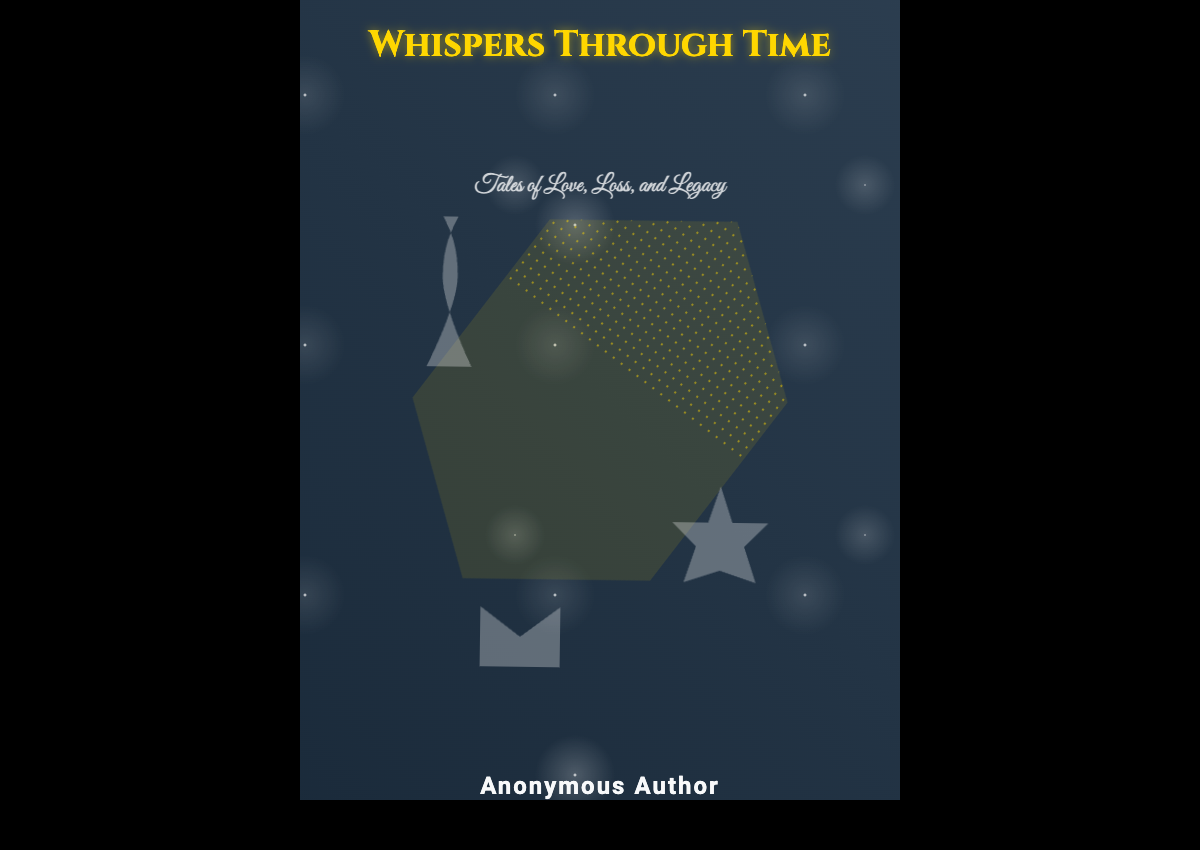What is the title of the book? The title is prominently displayed at the top of the book cover.
Answer: Whispers Through Time What is the subtitle of the book? The subtitle is shown below the title, indicating the theme of the stories.
Answer: Tales of Love, Loss, and Legacy Who is the author of the book? The author's name is listed at the bottom of the cover in a clear font.
Answer: Anonymous Author What shape is the hourglass? The hourglass can be identified by its unique form depicted in the design.
Answer: Ethereal How many ghostly images are displayed? There are three ghostly images shown within the hourglass.
Answer: Three What color is the text for the title? The color of the title text is a striking feature of the book cover.
Answer: Golden What element is used to describe the background theme? The theme is conveyed through the starry background animation.
Answer: Celestial What is the main visual element in the center of the cover? The focal point of the cover is the hourglass, which contains the celestial sand.
Answer: Hourglass What is the transparency level of the ghostly images? The ghostly images have a noticeable visibility level that contributes to the ethereal effect.
Answer: 0.3 